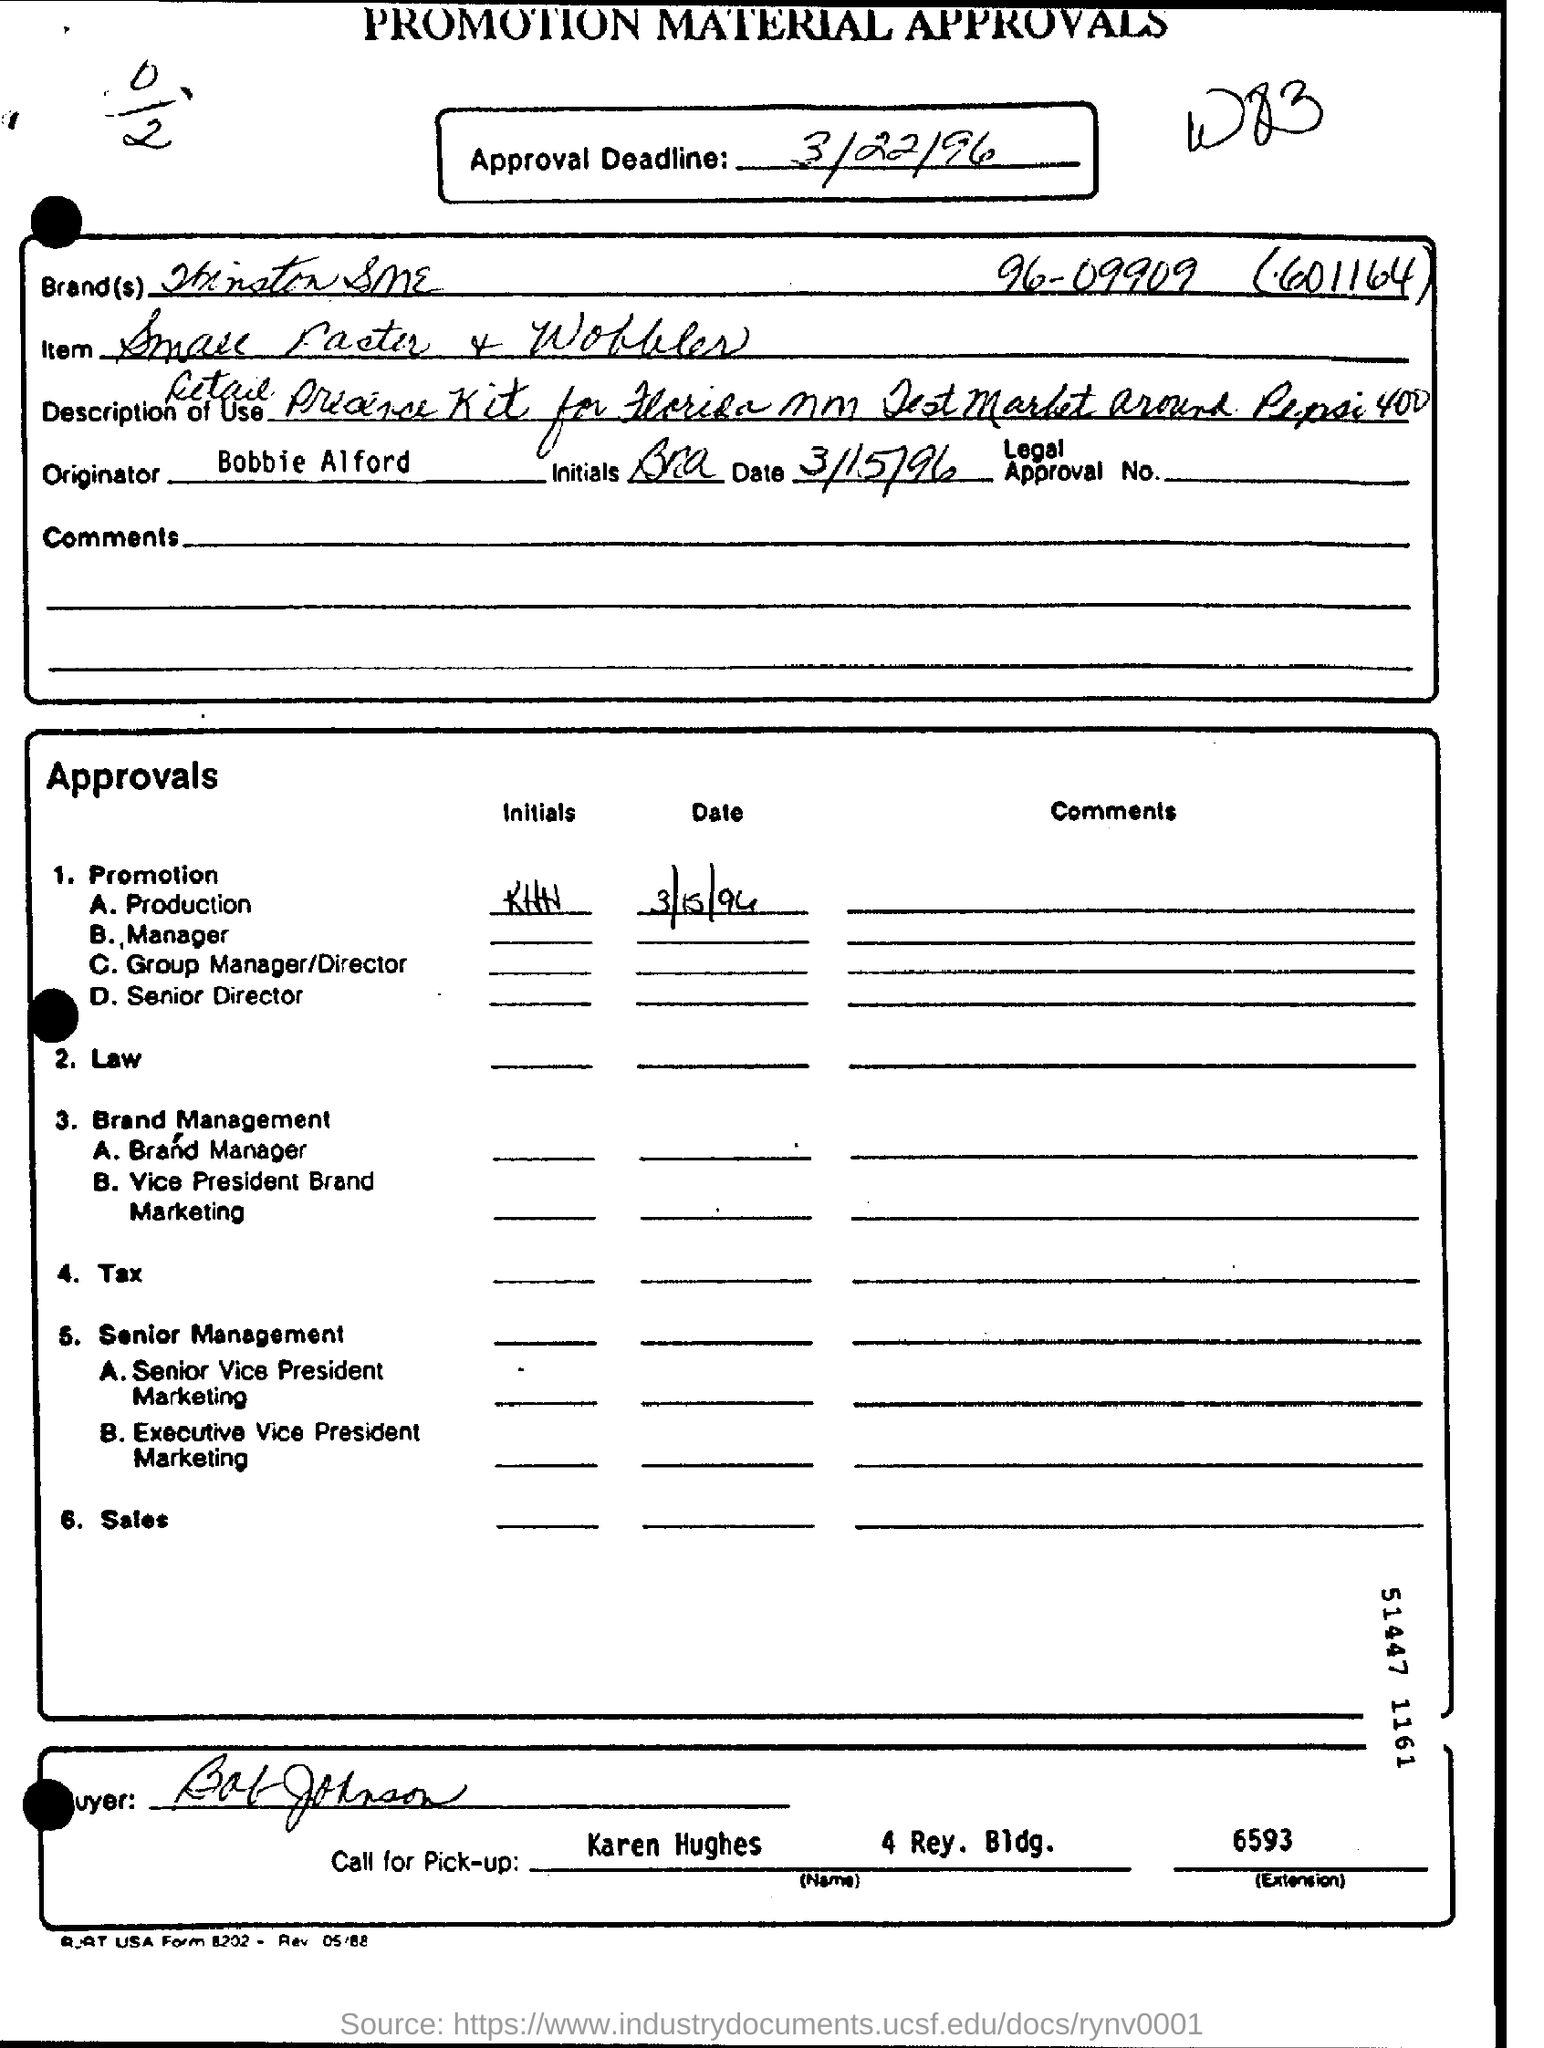What is the Approval Deadline?
Provide a succinct answer. 3/22/96. Whom should one call for pick up
Your answer should be very brief. Karen Hughes. Who is the originator?
Give a very brief answer. Bobbie Alford. What is the extension number of Karen Hughes?
Provide a short and direct response. 6593. 